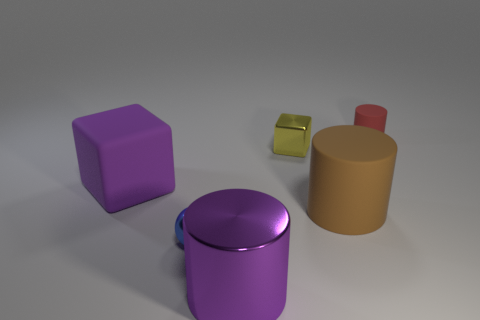What color is the matte object that is in front of the small red cylinder and right of the large purple matte object?
Ensure brevity in your answer.  Brown. What size is the purple object that is in front of the large thing behind the matte cylinder that is in front of the tiny red thing?
Your answer should be compact. Large. How many things are cylinders that are in front of the small red cylinder or tiny metal things that are in front of the brown cylinder?
Make the answer very short. 3. What shape is the yellow object?
Offer a terse response. Cube. What is the size of the purple thing that is the same shape as the big brown thing?
Provide a succinct answer. Large. What material is the blue object that is in front of the shiny thing that is to the right of the large purple object on the right side of the small blue object?
Provide a succinct answer. Metal. Is there a purple cube?
Your answer should be compact. Yes. There is a large block; does it have the same color as the object that is in front of the small blue shiny sphere?
Offer a terse response. Yes. The large metal cylinder is what color?
Offer a terse response. Purple. Are there any other things that have the same shape as the small yellow thing?
Ensure brevity in your answer.  Yes. 